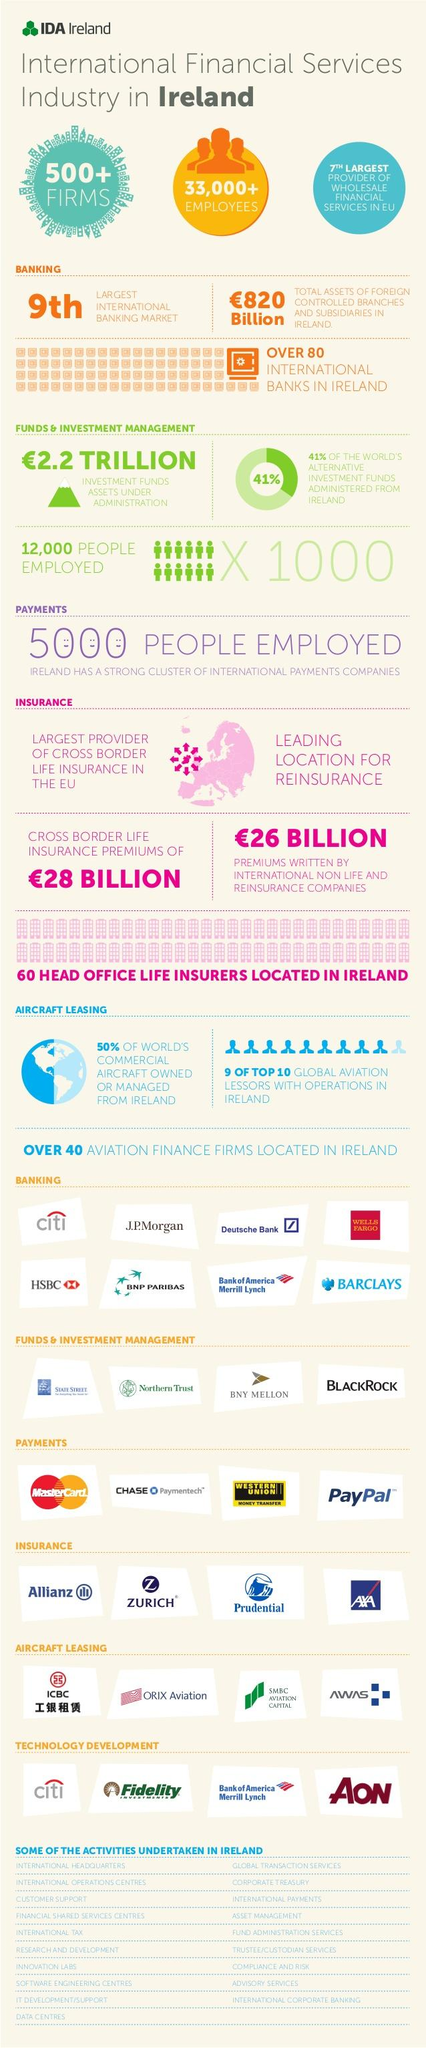Outline some significant characteristics in this image. Approximately 33,000 or more employees are currently working in the international financial services sector in Ireland. 